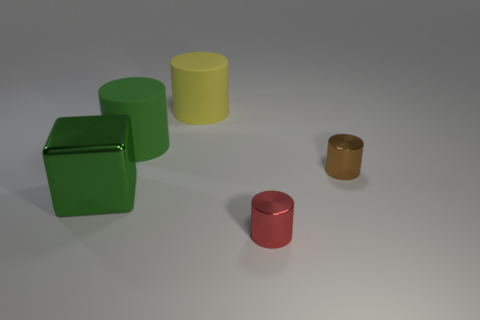Is the number of green rubber cylinders right of the large green matte cylinder less than the number of small brown shiny objects that are to the right of the small brown cylinder?
Offer a very short reply. No. What color is the other large object that is the same shape as the yellow object?
Provide a short and direct response. Green. Does the tiny brown metallic object have the same shape as the big yellow object?
Your response must be concise. Yes. The shiny thing that is the same size as the green rubber cylinder is what color?
Make the answer very short. Green. Is the block the same size as the green matte thing?
Provide a short and direct response. Yes. What shape is the big rubber thing that is the same color as the shiny cube?
Your answer should be very brief. Cylinder. What color is the object that is behind the large green cube and in front of the large green cylinder?
Provide a succinct answer. Brown. Is the number of cylinders behind the brown thing greater than the number of green blocks that are behind the big yellow thing?
Offer a very short reply. Yes. There is a red object that is the same material as the cube; what is its size?
Make the answer very short. Small. There is a green thing on the right side of the metallic cube; how many shiny cylinders are right of it?
Offer a very short reply. 2. 